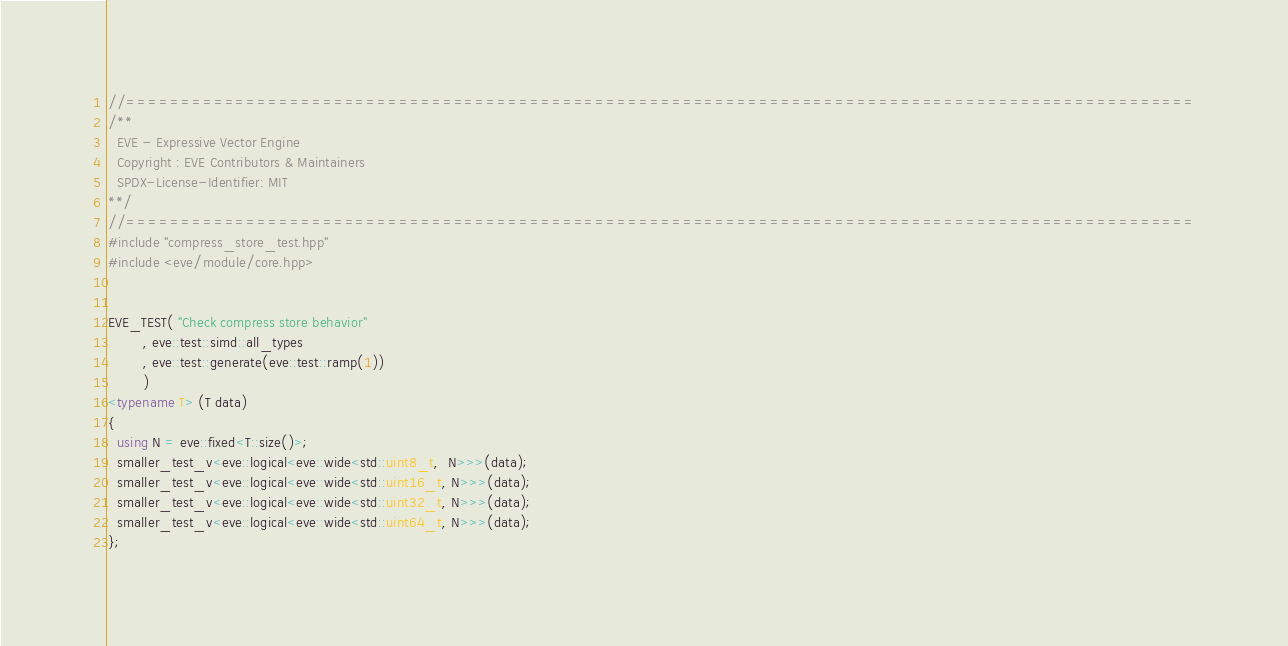<code> <loc_0><loc_0><loc_500><loc_500><_C++_>//==================================================================================================
/**
  EVE - Expressive Vector Engine
  Copyright : EVE Contributors & Maintainers
  SPDX-License-Identifier: MIT
**/
//==================================================================================================
#include "compress_store_test.hpp"
#include <eve/module/core.hpp>


EVE_TEST( "Check compress store behavior"
        , eve::test::simd::all_types
        , eve::test::generate(eve::test::ramp(1))
        )
<typename T> (T data)
{
  using N = eve::fixed<T::size()>;
  smaller_test_v<eve::logical<eve::wide<std::uint8_t,  N>>>(data);
  smaller_test_v<eve::logical<eve::wide<std::uint16_t, N>>>(data);
  smaller_test_v<eve::logical<eve::wide<std::uint32_t, N>>>(data);
  smaller_test_v<eve::logical<eve::wide<std::uint64_t, N>>>(data);
};
</code> 